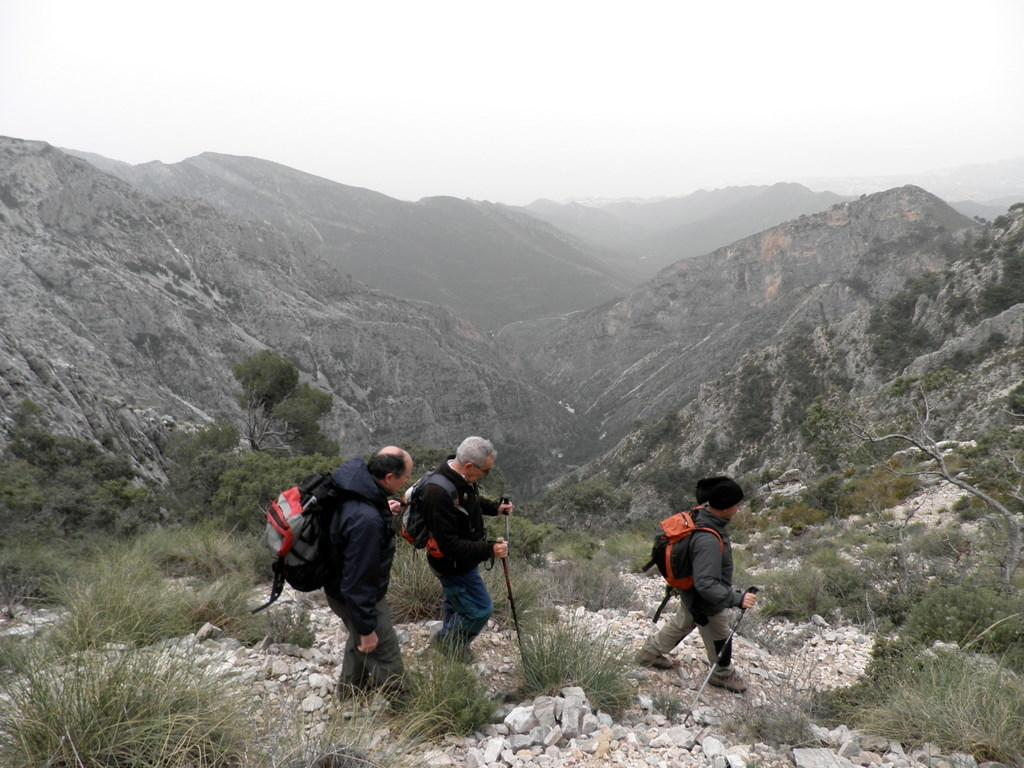How many persons are in the image? There are persons in the image, but the exact number is not specified. What are the persons wearing in the image? The persons are wearing bags in the image. In which direction are the persons facing? The persons are facing towards the right side of the image. What type of vegetation can be seen in the image? There are plants in the image. What can be seen in the background of the image? There are mountains in the background of the image. How many lizards are participating in the competition in the image? There are no lizards or competition present in the image. What type of apple can be seen in the hands of the persons in the image? There are no apples present in the image. 